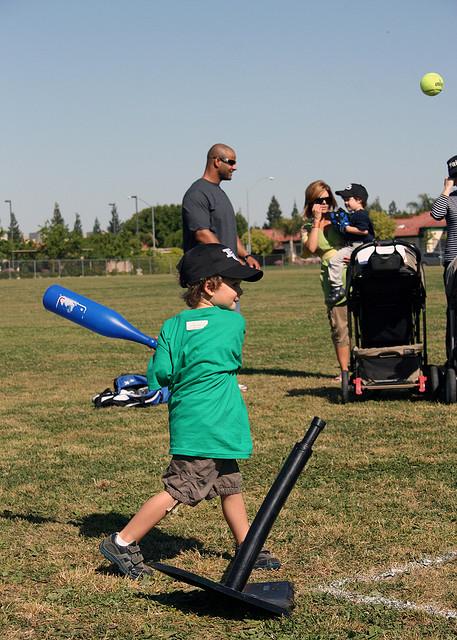How many sunglasses?
Write a very short answer. 2. Does the man look happy?
Short answer required. Yes. What is in the air?
Keep it brief. Ball. What is the boy learning to do?
Write a very short answer. Baseball. Is this man wearing sunglasses?
Be succinct. Yes. What type of balls are in the photo?
Answer briefly. Baseball. What are the people playing?
Quick response, please. Baseball. Is this young boy holding a blue bat?
Answer briefly. Yes. What color are the tennis balls?
Answer briefly. Green. Did he use a baseball tee to hit the ball?
Keep it brief. Yes. 